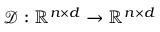<formula> <loc_0><loc_0><loc_500><loc_500>\mathcal { D } \colon \mathbb { R } ^ { n \times d } \rightarrow \mathbb { R } ^ { n \times d }</formula> 